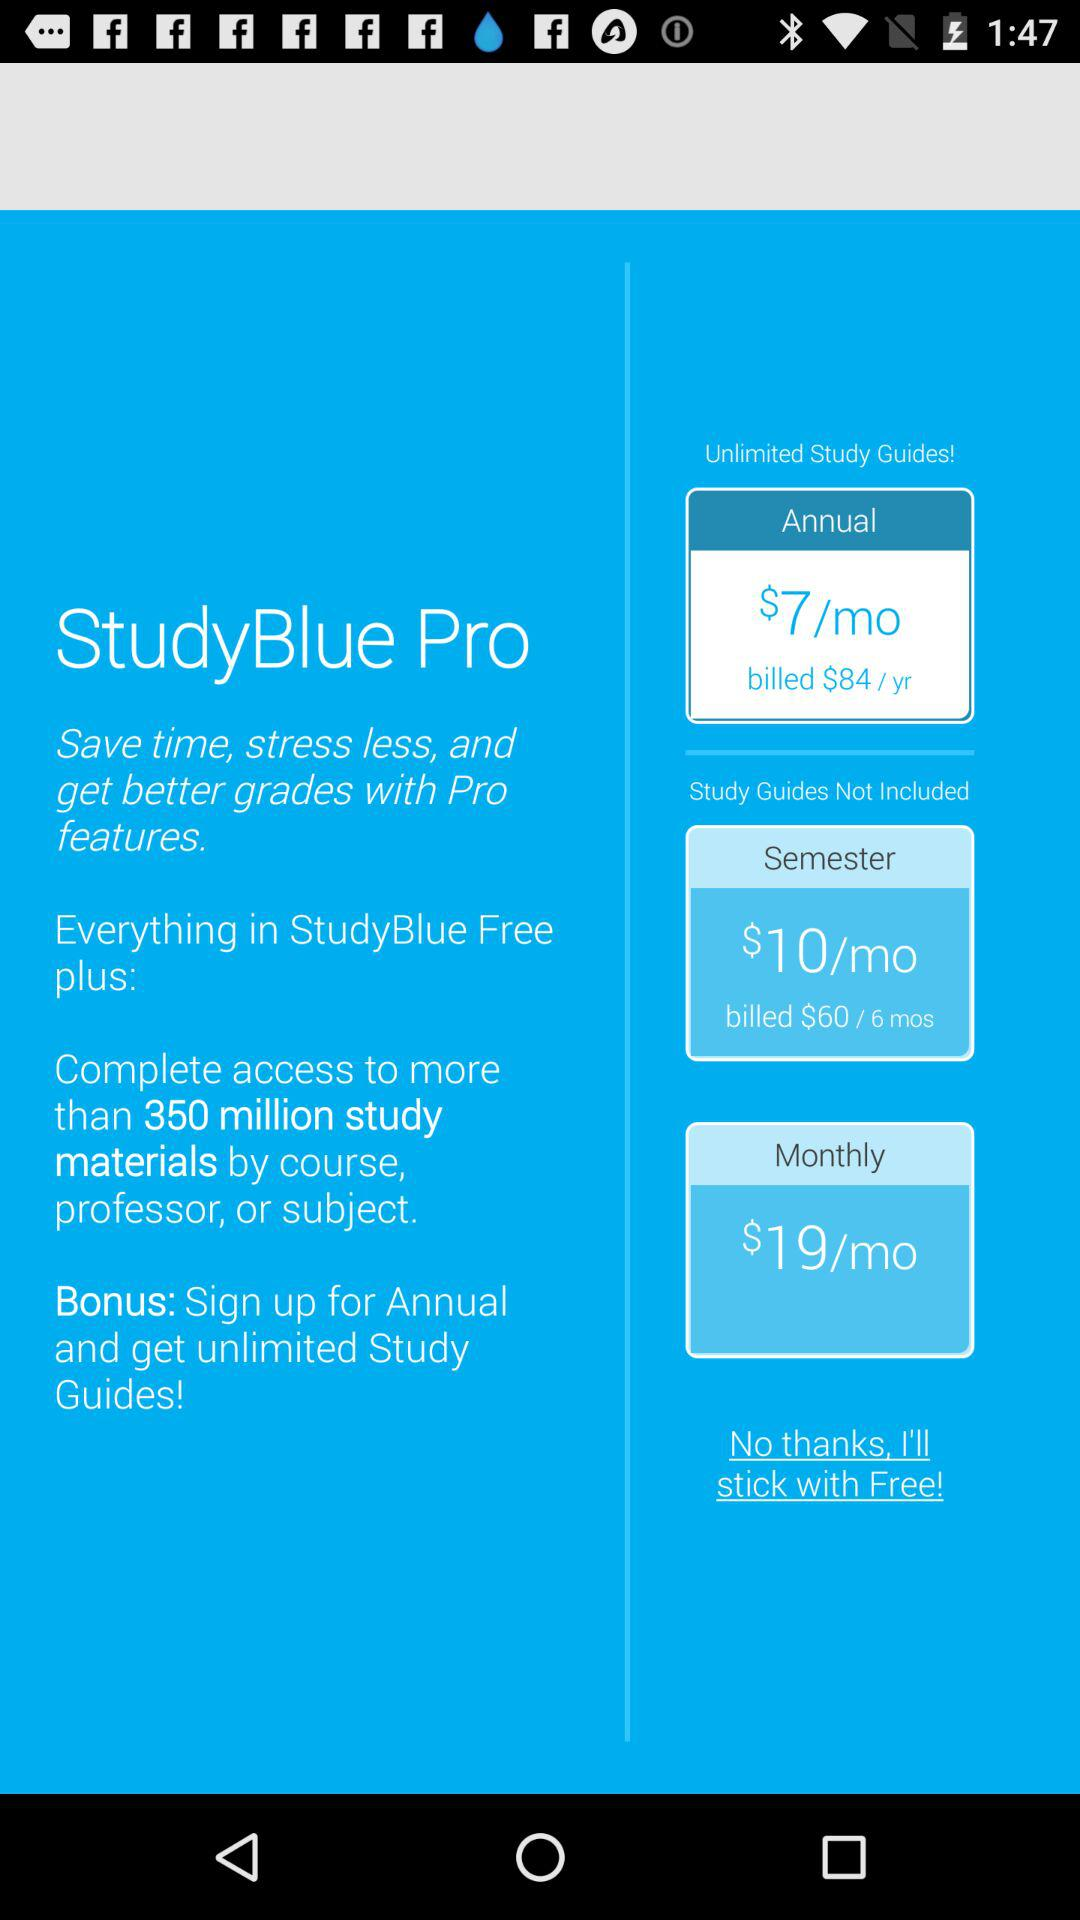What is the semester cost? The semester cost is $10/mo. 